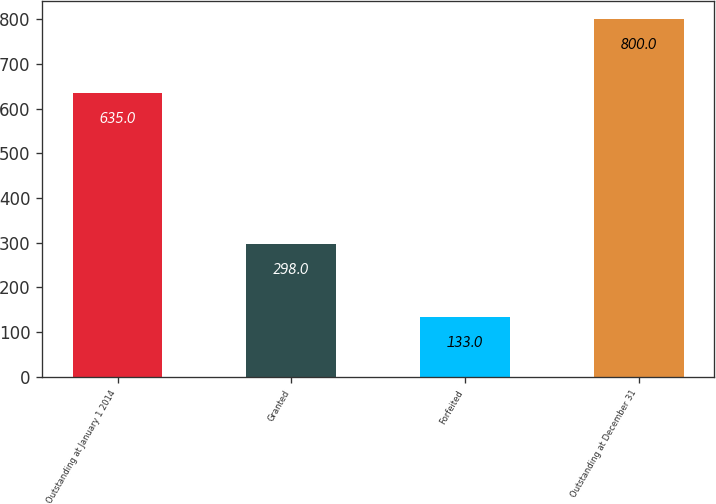<chart> <loc_0><loc_0><loc_500><loc_500><bar_chart><fcel>Outstanding at January 1 2014<fcel>Granted<fcel>Forfeited<fcel>Outstanding at December 31<nl><fcel>635<fcel>298<fcel>133<fcel>800<nl></chart> 